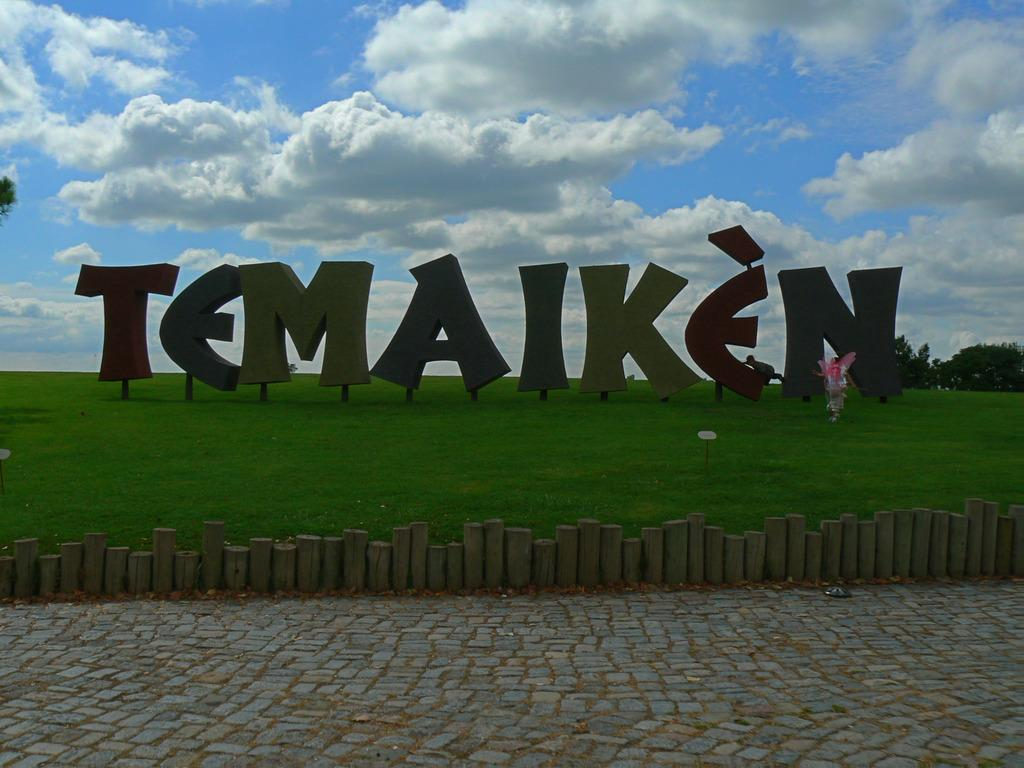What is located in the middle of the image? There are alphabets in the middle of the image. What type of vegetation is at the top of the image? There is grass at the top of the image. What is visible at the top of the image? The sky is visible at the top of the image. How does the sky appear in the image? The sky appears to be sunny in the image. Can you tell me how many pets are visible on the roof in the image? There is no roof or pet present in the image. What type of pet is playing with the alphabets in the image? There is no pet present in the image, and the alphabets are not being played with. 